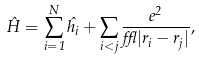Convert formula to latex. <formula><loc_0><loc_0><loc_500><loc_500>\hat { H } = \sum _ { i = 1 } ^ { N } \hat { h _ { i } } + \sum _ { i < j } \frac { e ^ { 2 } } { \epsilon { | r _ { i } - r _ { j } | } } ,</formula> 